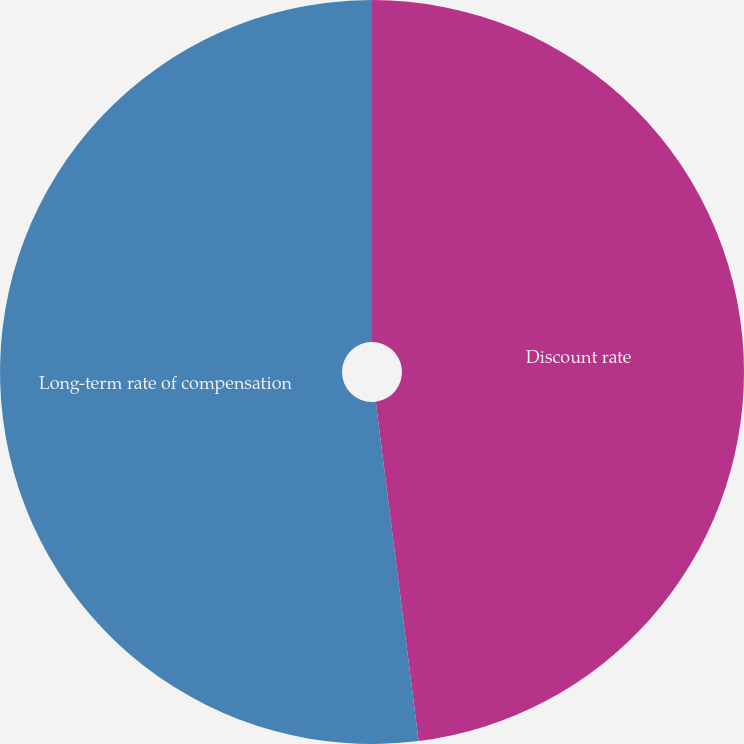Convert chart to OTSL. <chart><loc_0><loc_0><loc_500><loc_500><pie_chart><fcel>Discount rate<fcel>Long-term rate of compensation<nl><fcel>48.0%<fcel>52.0%<nl></chart> 